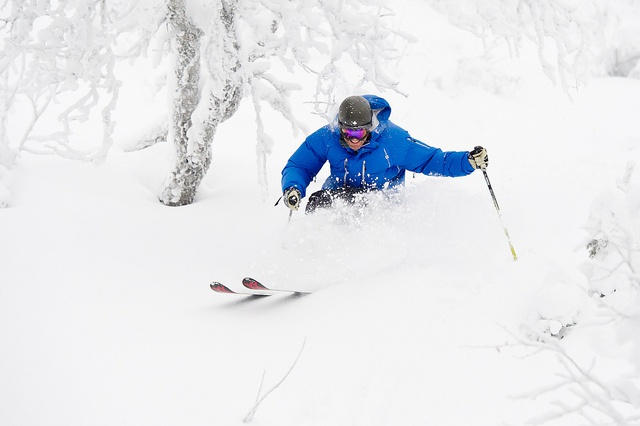Describe the objects in this image and their specific colors. I can see people in white, blue, darkblue, and gray tones and skis in white, lightgray, gray, darkgray, and brown tones in this image. 